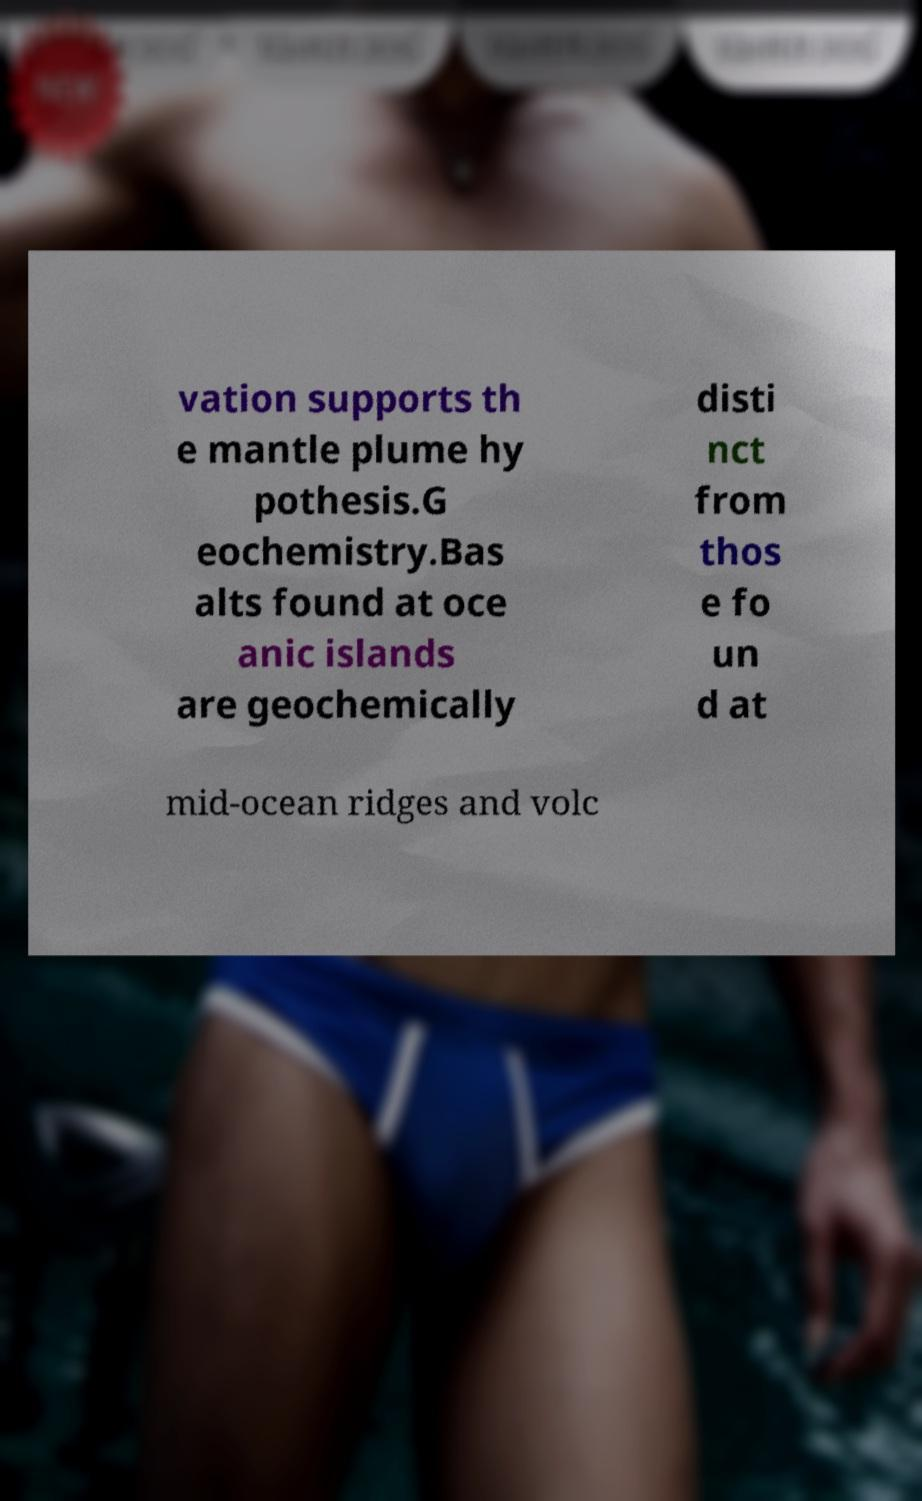Can you read and provide the text displayed in the image?This photo seems to have some interesting text. Can you extract and type it out for me? vation supports th e mantle plume hy pothesis.G eochemistry.Bas alts found at oce anic islands are geochemically disti nct from thos e fo un d at mid-ocean ridges and volc 